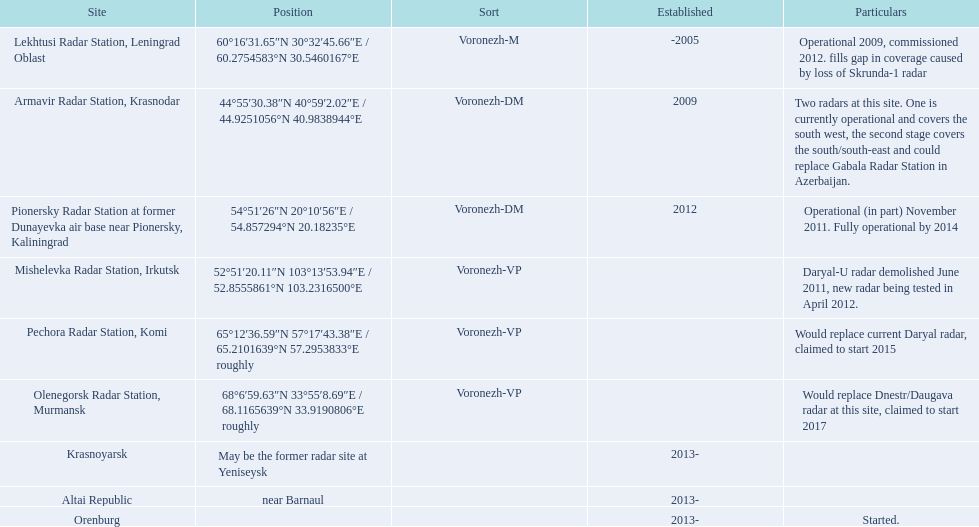How many voronezh radars are present in kaliningrad or krasnodar? 2. 